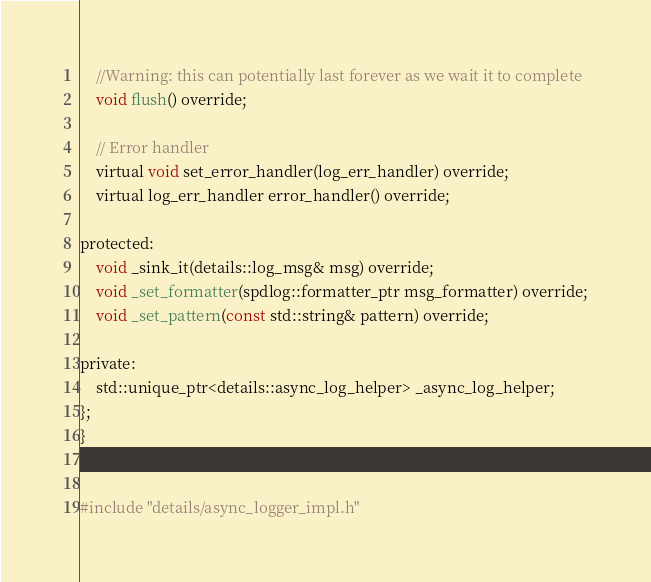Convert code to text. <code><loc_0><loc_0><loc_500><loc_500><_C_>    //Warning: this can potentially last forever as we wait it to complete
    void flush() override;

    // Error handler
    virtual void set_error_handler(log_err_handler) override;
    virtual log_err_handler error_handler() override;

protected:
    void _sink_it(details::log_msg& msg) override;
    void _set_formatter(spdlog::formatter_ptr msg_formatter) override;
    void _set_pattern(const std::string& pattern) override;

private:
    std::unique_ptr<details::async_log_helper> _async_log_helper;
};
}


#include "details/async_logger_impl.h"
</code> 